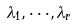<formula> <loc_0><loc_0><loc_500><loc_500>\lambda _ { 1 } , \cdot \cdot \cdot , \lambda _ { r }</formula> 